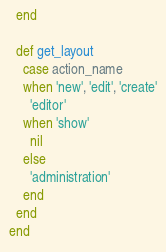<code> <loc_0><loc_0><loc_500><loc_500><_Ruby_>  end

  def get_layout
    case action_name
    when 'new', 'edit', 'create'
      'editor'
    when 'show'
      nil
    else
      'administration'
    end
  end
end
</code> 